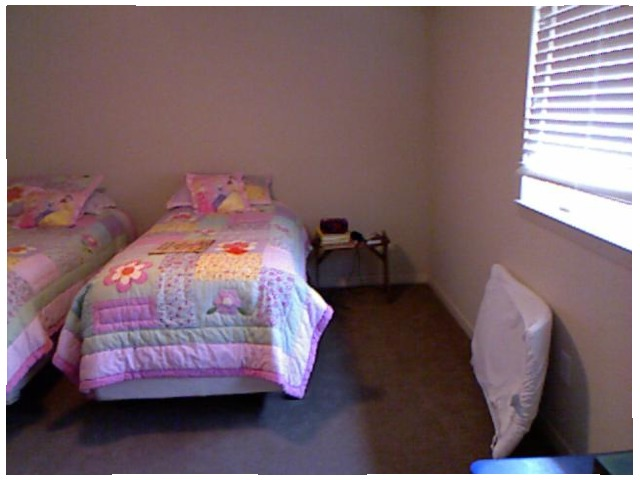<image>
Is there a bed in front of the pillow? Yes. The bed is positioned in front of the pillow, appearing closer to the camera viewpoint. Is the bed to the right of the phone? No. The bed is not to the right of the phone. The horizontal positioning shows a different relationship. 